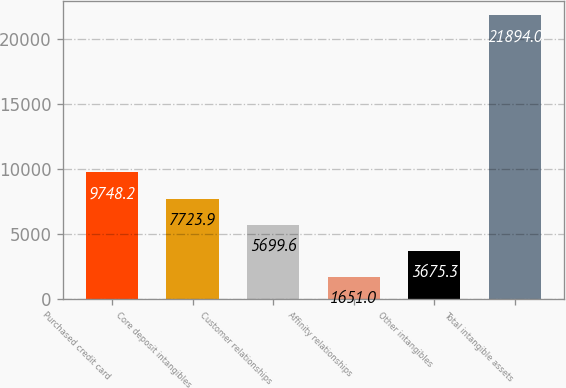Convert chart to OTSL. <chart><loc_0><loc_0><loc_500><loc_500><bar_chart><fcel>Purchased credit card<fcel>Core deposit intangibles<fcel>Customer relationships<fcel>Affinity relationships<fcel>Other intangibles<fcel>Total intangible assets<nl><fcel>9748.2<fcel>7723.9<fcel>5699.6<fcel>1651<fcel>3675.3<fcel>21894<nl></chart> 